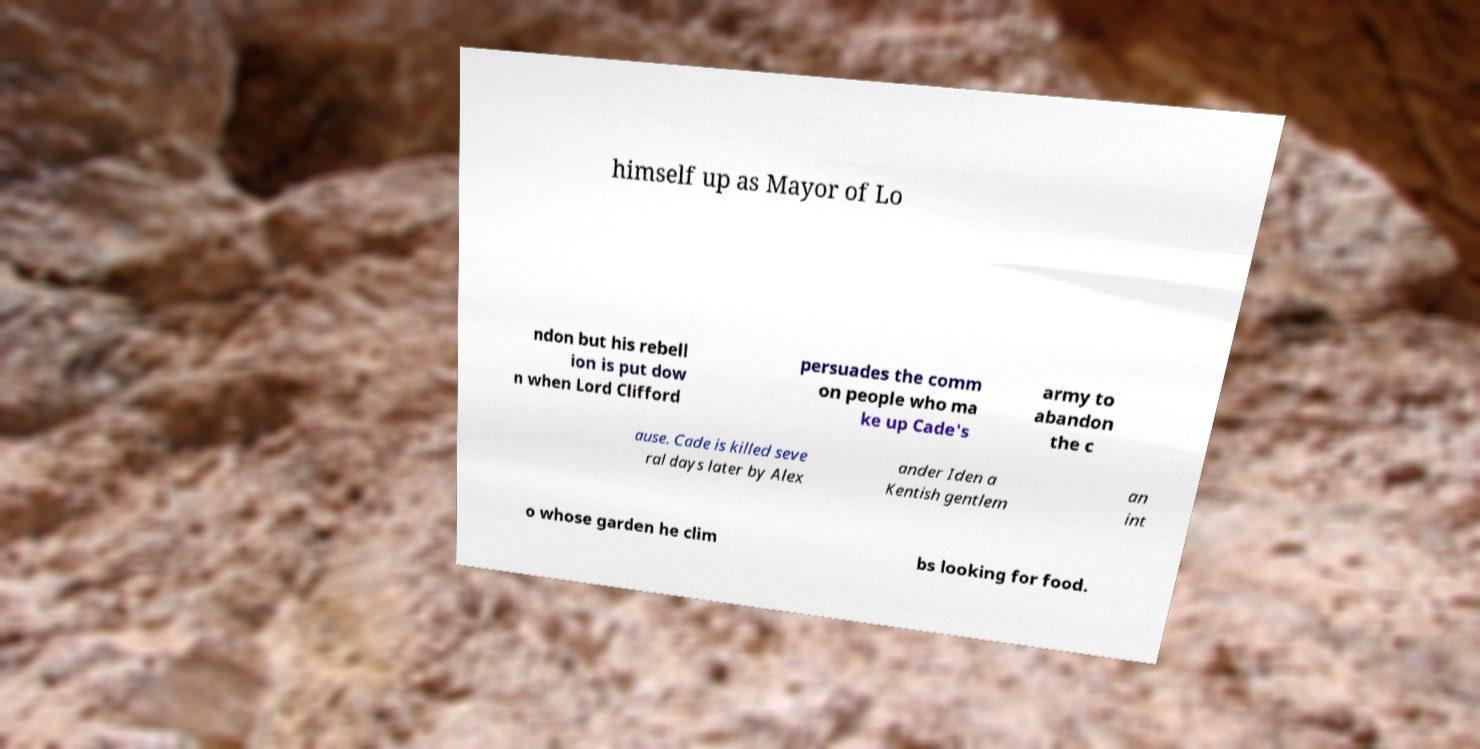Can you read and provide the text displayed in the image?This photo seems to have some interesting text. Can you extract and type it out for me? himself up as Mayor of Lo ndon but his rebell ion is put dow n when Lord Clifford persuades the comm on people who ma ke up Cade's army to abandon the c ause. Cade is killed seve ral days later by Alex ander Iden a Kentish gentlem an int o whose garden he clim bs looking for food. 